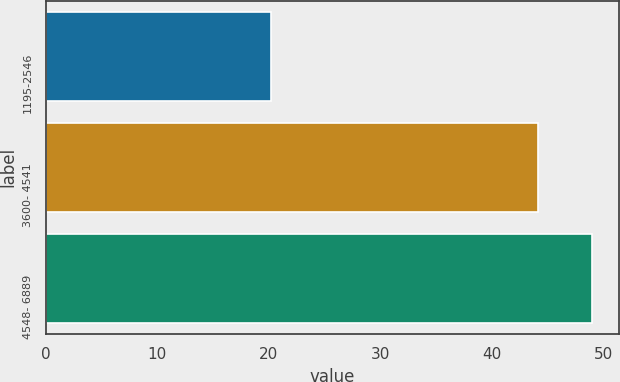<chart> <loc_0><loc_0><loc_500><loc_500><bar_chart><fcel>1195-2546<fcel>3600- 4541<fcel>4548- 6889<nl><fcel>20.22<fcel>44.13<fcel>48.99<nl></chart> 